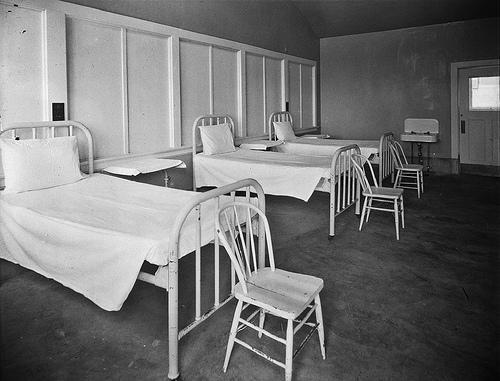This room looks like an old type of what?
Make your selection from the four choices given to correctly answer the question.
Options: School, church, hospital, prison. Hospital. 